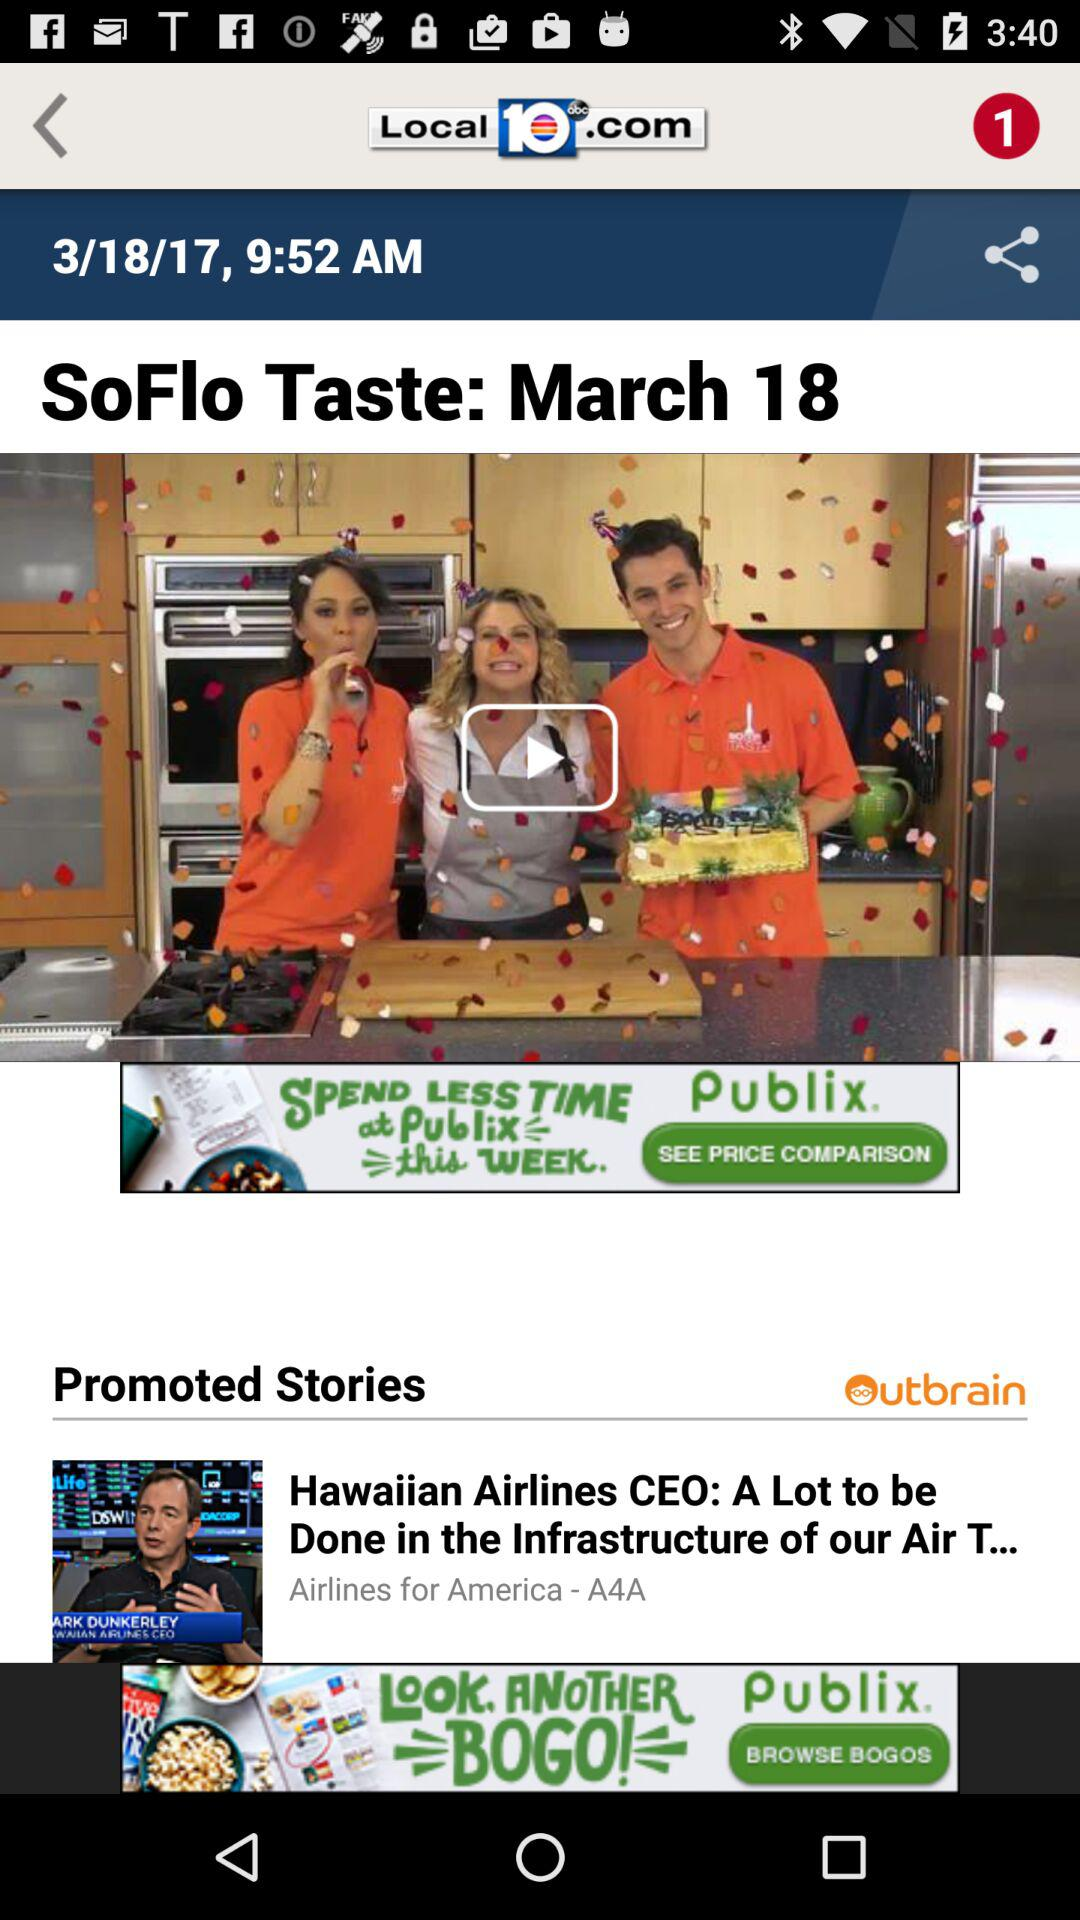What is the time? The time is 9:52 a.m. 